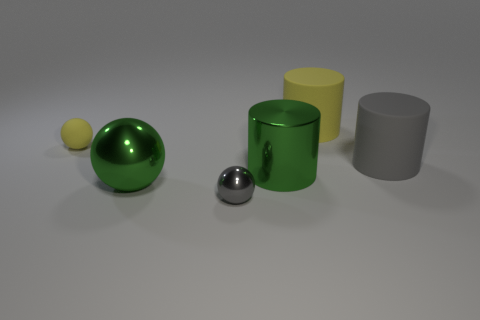What is the small thing behind the big matte thing in front of the tiny ball that is behind the gray cylinder made of?
Provide a succinct answer. Rubber. What is the color of the small thing that is the same material as the big yellow cylinder?
Provide a short and direct response. Yellow. Is the material of the small yellow object the same as the yellow thing on the right side of the yellow sphere?
Provide a succinct answer. Yes. How many small gray things are made of the same material as the big ball?
Provide a succinct answer. 1. What is the shape of the thing behind the yellow rubber sphere?
Ensure brevity in your answer.  Cylinder. Is the material of the tiny ball that is in front of the large green metal cylinder the same as the gray object on the right side of the yellow matte cylinder?
Make the answer very short. No. Is there another small rubber object of the same shape as the small yellow rubber object?
Give a very brief answer. No. How many things are yellow objects that are to the right of the metal cylinder or rubber things?
Your answer should be compact. 3. Is the number of small gray shiny balls to the right of the tiny yellow matte thing greater than the number of large gray matte cylinders that are left of the large gray rubber cylinder?
Give a very brief answer. Yes. What number of rubber things are big purple things or green spheres?
Keep it short and to the point. 0. 